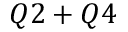<formula> <loc_0><loc_0><loc_500><loc_500>Q 2 + Q 4</formula> 